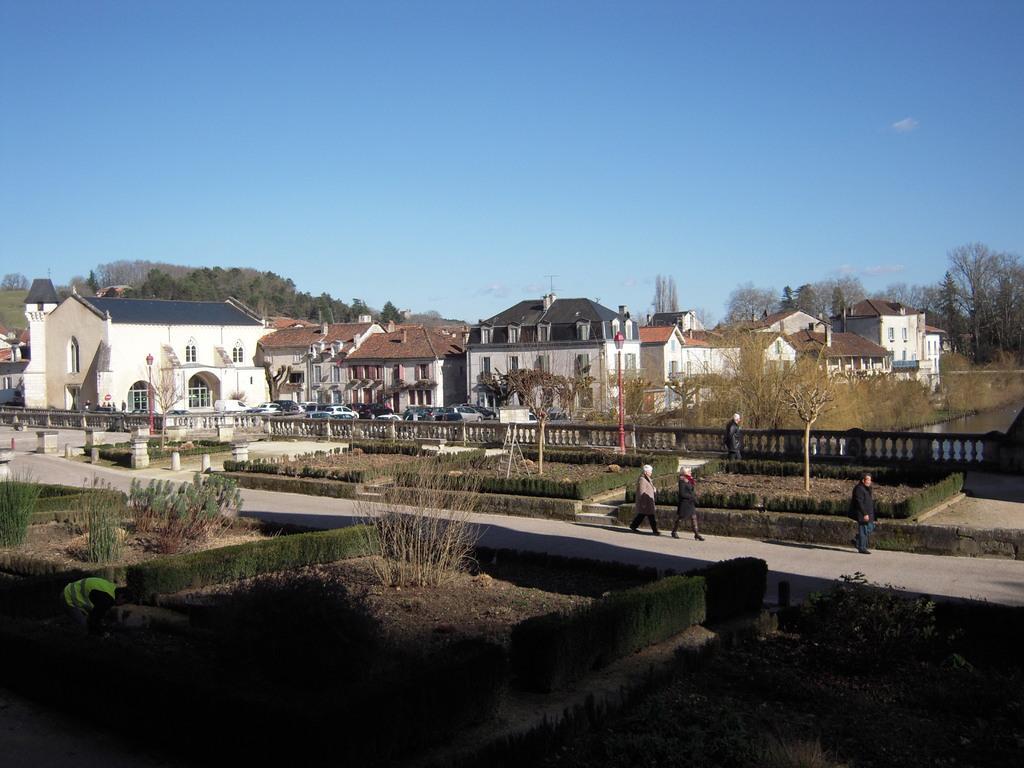Please provide a concise description of this image. In the foreground of the picture there are plants, road and people. In the center of the picture there are houses, car, railing, street lights, plants and trees. Sky is clear and it is sunny. 